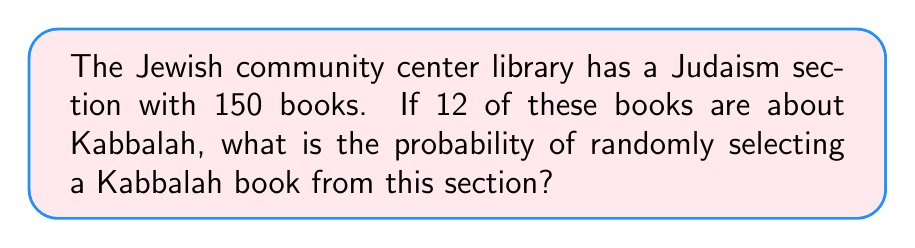Help me with this question. To solve this problem, we need to use the concept of probability. The probability of an event is calculated by dividing the number of favorable outcomes by the total number of possible outcomes.

1. Identify the total number of books in the Judaism section:
   Total books = 150

2. Identify the number of Kabbalah books:
   Kabbalah books = 12

3. Calculate the probability:
   $$P(\text{Kabbalah book}) = \frac{\text{Number of Kabbalah books}}{\text{Total number of books}}$$
   
   $$P(\text{Kabbalah book}) = \frac{12}{150}$$

4. Simplify the fraction:
   $$P(\text{Kabbalah book}) = \frac{12}{150} = \frac{2}{25} = 0.08$$

Therefore, the probability of randomly selecting a Kabbalah book from the Judaism section is $\frac{2}{25}$ or 0.08 or 8%.
Answer: $\frac{2}{25}$ or 0.08 